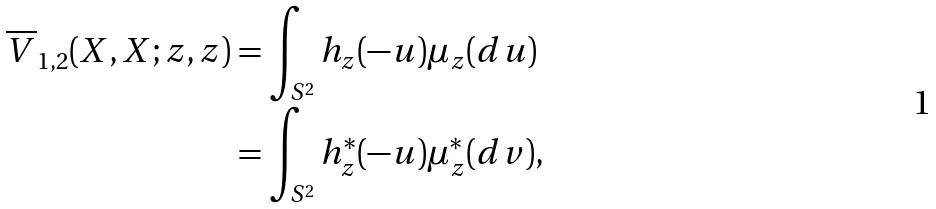<formula> <loc_0><loc_0><loc_500><loc_500>\overline { V } _ { 1 , 2 } ( X , X ; z , z ) & = \int _ { S ^ { 2 } } h _ { z } ( - u ) \mu _ { z } ( d u ) \\ & = \int _ { S ^ { 2 } } h _ { z } ^ { * } ( - u ) \mu _ { z } ^ { * } ( d v ) ,</formula> 